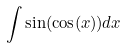<formula> <loc_0><loc_0><loc_500><loc_500>\int \sin ( \cos ( x ) ) d x</formula> 